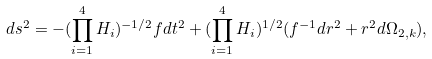Convert formula to latex. <formula><loc_0><loc_0><loc_500><loc_500>d s ^ { 2 } = - ( \prod _ { i = 1 } ^ { 4 } H _ { i } ) ^ { - 1 / 2 } f d t ^ { 2 } + ( \prod _ { i = 1 } ^ { 4 } H _ { i } ) ^ { 1 / 2 } ( f ^ { - 1 } d r ^ { 2 } + r ^ { 2 } d \Omega _ { 2 , k } ) ,</formula> 